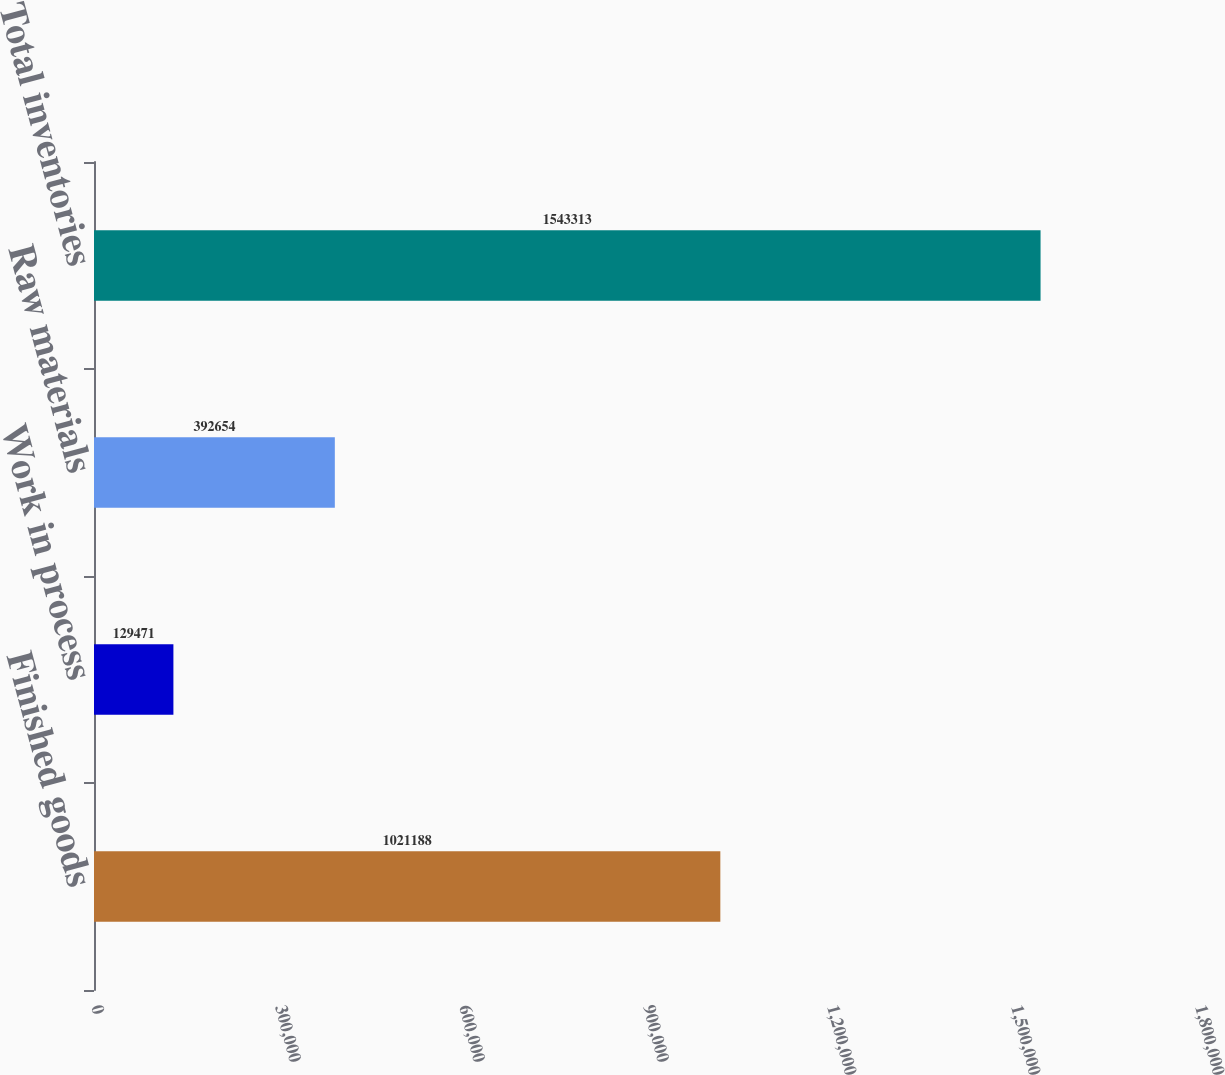Convert chart to OTSL. <chart><loc_0><loc_0><loc_500><loc_500><bar_chart><fcel>Finished goods<fcel>Work in process<fcel>Raw materials<fcel>Total inventories<nl><fcel>1.02119e+06<fcel>129471<fcel>392654<fcel>1.54331e+06<nl></chart> 